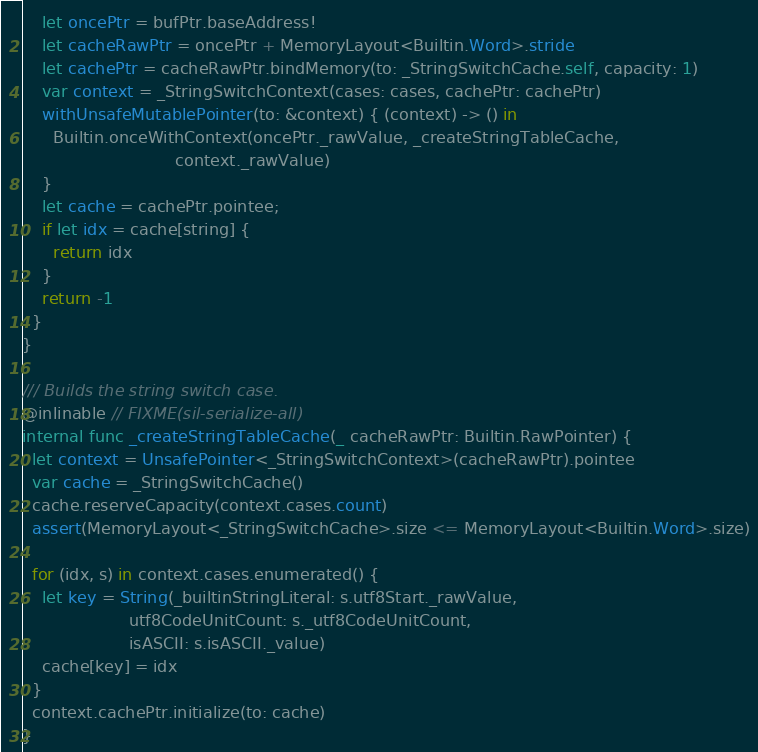Convert code to text. <code><loc_0><loc_0><loc_500><loc_500><_Swift_>
    let oncePtr = bufPtr.baseAddress!
    let cacheRawPtr = oncePtr + MemoryLayout<Builtin.Word>.stride
    let cachePtr = cacheRawPtr.bindMemory(to: _StringSwitchCache.self, capacity: 1)
    var context = _StringSwitchContext(cases: cases, cachePtr: cachePtr)
    withUnsafeMutablePointer(to: &context) { (context) -> () in
      Builtin.onceWithContext(oncePtr._rawValue, _createStringTableCache,
                              context._rawValue)
    }
    let cache = cachePtr.pointee;
    if let idx = cache[string] {
      return idx
    }
    return -1
  }
}

/// Builds the string switch case.
@inlinable // FIXME(sil-serialize-all)
internal func _createStringTableCache(_ cacheRawPtr: Builtin.RawPointer) {
  let context = UnsafePointer<_StringSwitchContext>(cacheRawPtr).pointee
  var cache = _StringSwitchCache()
  cache.reserveCapacity(context.cases.count)
  assert(MemoryLayout<_StringSwitchCache>.size <= MemoryLayout<Builtin.Word>.size)

  for (idx, s) in context.cases.enumerated() {
    let key = String(_builtinStringLiteral: s.utf8Start._rawValue,
                     utf8CodeUnitCount: s._utf8CodeUnitCount,
                     isASCII: s.isASCII._value)
    cache[key] = idx
  }
  context.cachePtr.initialize(to: cache)
}

</code> 